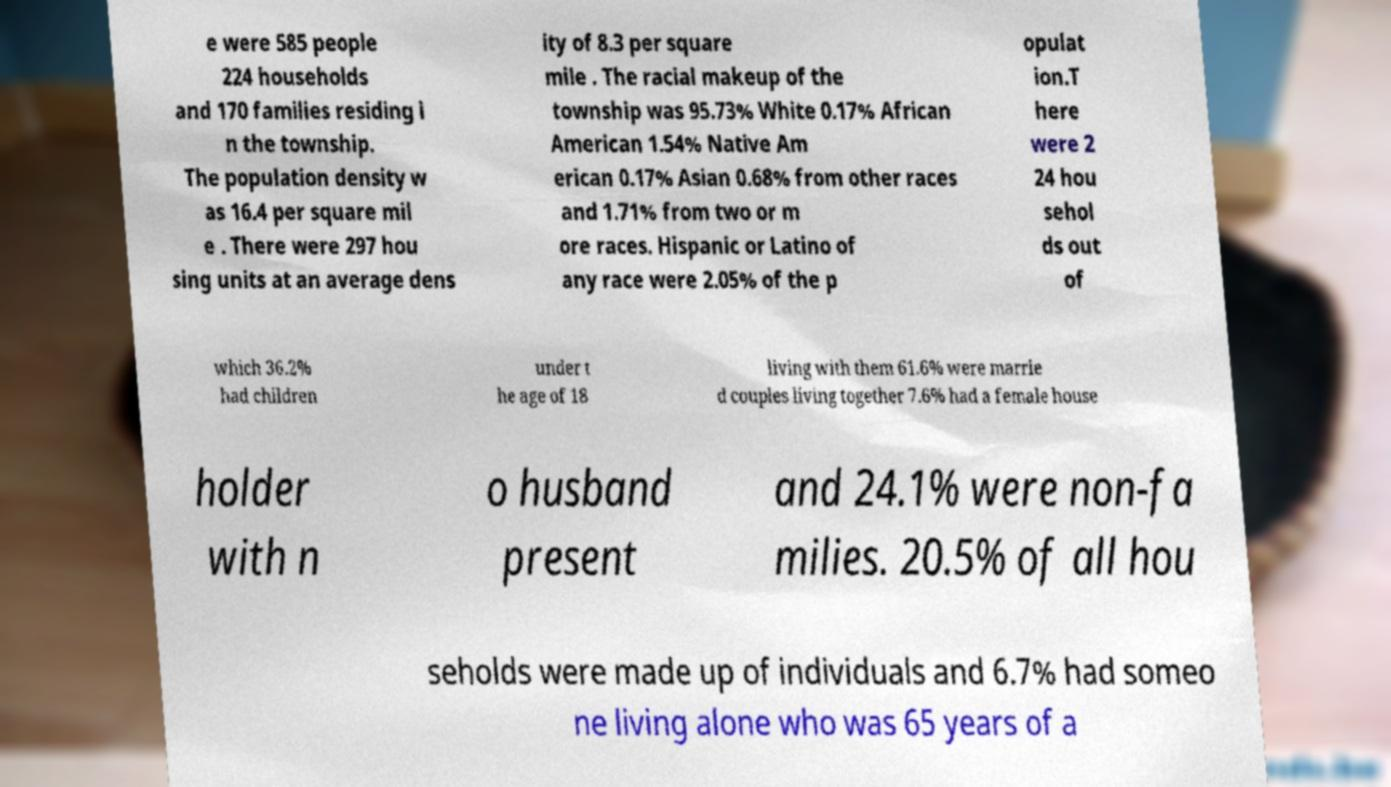Please identify and transcribe the text found in this image. e were 585 people 224 households and 170 families residing i n the township. The population density w as 16.4 per square mil e . There were 297 hou sing units at an average dens ity of 8.3 per square mile . The racial makeup of the township was 95.73% White 0.17% African American 1.54% Native Am erican 0.17% Asian 0.68% from other races and 1.71% from two or m ore races. Hispanic or Latino of any race were 2.05% of the p opulat ion.T here were 2 24 hou sehol ds out of which 36.2% had children under t he age of 18 living with them 61.6% were marrie d couples living together 7.6% had a female house holder with n o husband present and 24.1% were non-fa milies. 20.5% of all hou seholds were made up of individuals and 6.7% had someo ne living alone who was 65 years of a 